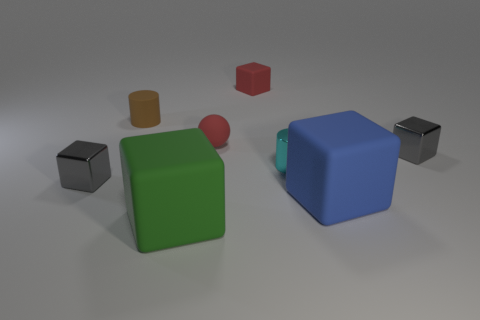Subtract all big green blocks. How many blocks are left? 4 Subtract all blue cylinders. How many gray cubes are left? 2 Subtract all blue blocks. How many blocks are left? 4 Subtract 1 cubes. How many cubes are left? 4 Subtract all blocks. How many objects are left? 3 Add 2 small objects. How many objects exist? 10 Subtract all brown blocks. Subtract all green spheres. How many blocks are left? 5 Subtract 0 yellow cylinders. How many objects are left? 8 Subtract all big purple shiny blocks. Subtract all cyan metallic things. How many objects are left? 7 Add 7 large blocks. How many large blocks are left? 9 